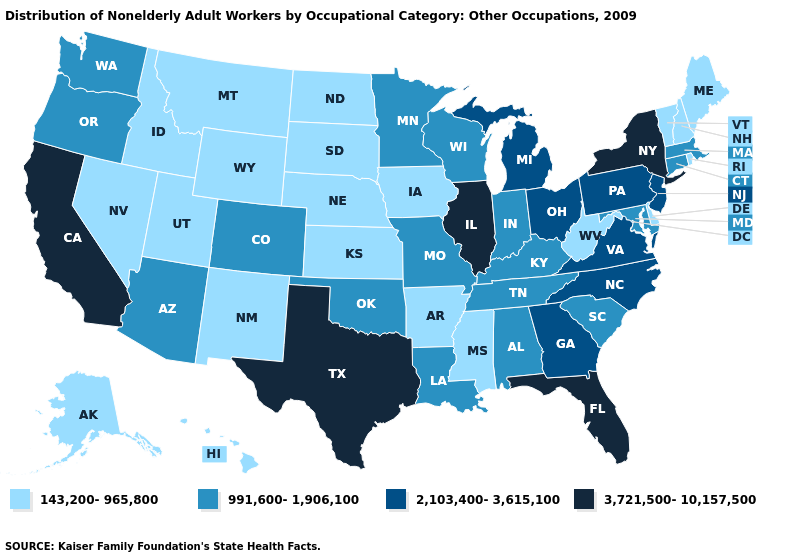Name the states that have a value in the range 143,200-965,800?
Keep it brief. Alaska, Arkansas, Delaware, Hawaii, Idaho, Iowa, Kansas, Maine, Mississippi, Montana, Nebraska, Nevada, New Hampshire, New Mexico, North Dakota, Rhode Island, South Dakota, Utah, Vermont, West Virginia, Wyoming. What is the value of Virginia?
Answer briefly. 2,103,400-3,615,100. Name the states that have a value in the range 991,600-1,906,100?
Keep it brief. Alabama, Arizona, Colorado, Connecticut, Indiana, Kentucky, Louisiana, Maryland, Massachusetts, Minnesota, Missouri, Oklahoma, Oregon, South Carolina, Tennessee, Washington, Wisconsin. Does California have the highest value in the West?
Write a very short answer. Yes. Among the states that border Idaho , which have the lowest value?
Keep it brief. Montana, Nevada, Utah, Wyoming. Among the states that border Wyoming , which have the lowest value?
Be succinct. Idaho, Montana, Nebraska, South Dakota, Utah. Among the states that border New York , does New Jersey have the highest value?
Be succinct. Yes. How many symbols are there in the legend?
Give a very brief answer. 4. What is the highest value in states that border Rhode Island?
Give a very brief answer. 991,600-1,906,100. Does the map have missing data?
Give a very brief answer. No. What is the highest value in states that border New Jersey?
Quick response, please. 3,721,500-10,157,500. Name the states that have a value in the range 143,200-965,800?
Answer briefly. Alaska, Arkansas, Delaware, Hawaii, Idaho, Iowa, Kansas, Maine, Mississippi, Montana, Nebraska, Nevada, New Hampshire, New Mexico, North Dakota, Rhode Island, South Dakota, Utah, Vermont, West Virginia, Wyoming. Does Ohio have the lowest value in the USA?
Quick response, please. No. What is the highest value in states that border Delaware?
Give a very brief answer. 2,103,400-3,615,100. What is the highest value in states that border Florida?
Write a very short answer. 2,103,400-3,615,100. 